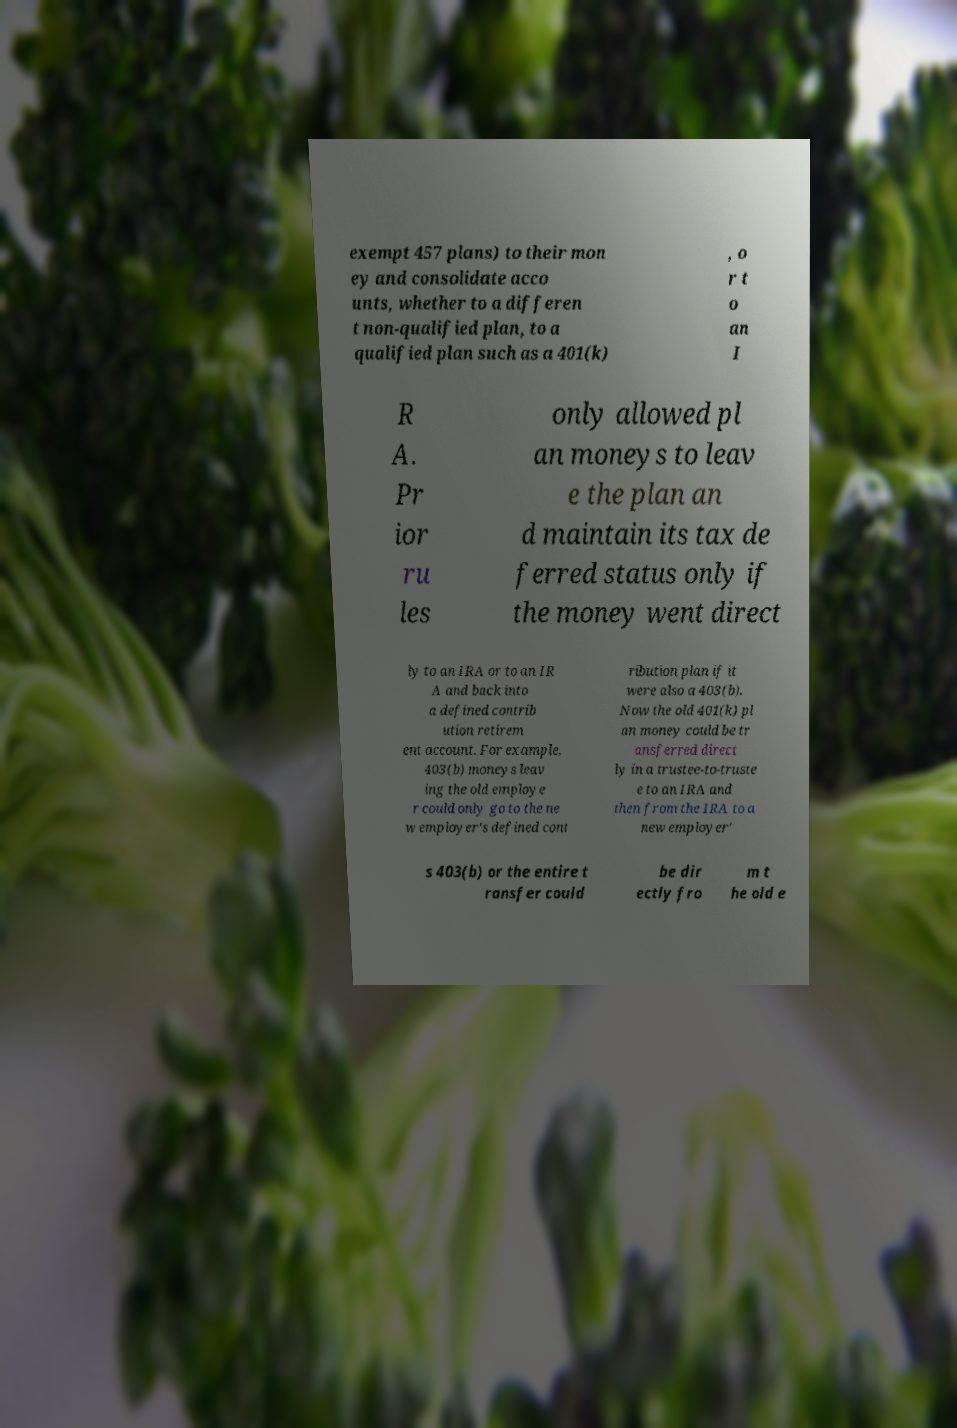What messages or text are displayed in this image? I need them in a readable, typed format. exempt 457 plans) to their mon ey and consolidate acco unts, whether to a differen t non-qualified plan, to a qualified plan such as a 401(k) , o r t o an I R A. Pr ior ru les only allowed pl an moneys to leav e the plan an d maintain its tax de ferred status only if the money went direct ly to an IRA or to an IR A and back into a defined contrib ution retirem ent account. For example, 403(b) moneys leav ing the old employe r could only go to the ne w employer's defined cont ribution plan if it were also a 403(b). Now the old 401(k) pl an money could be tr ansferred direct ly in a trustee-to-truste e to an IRA and then from the IRA to a new employer' s 403(b) or the entire t ransfer could be dir ectly fro m t he old e 